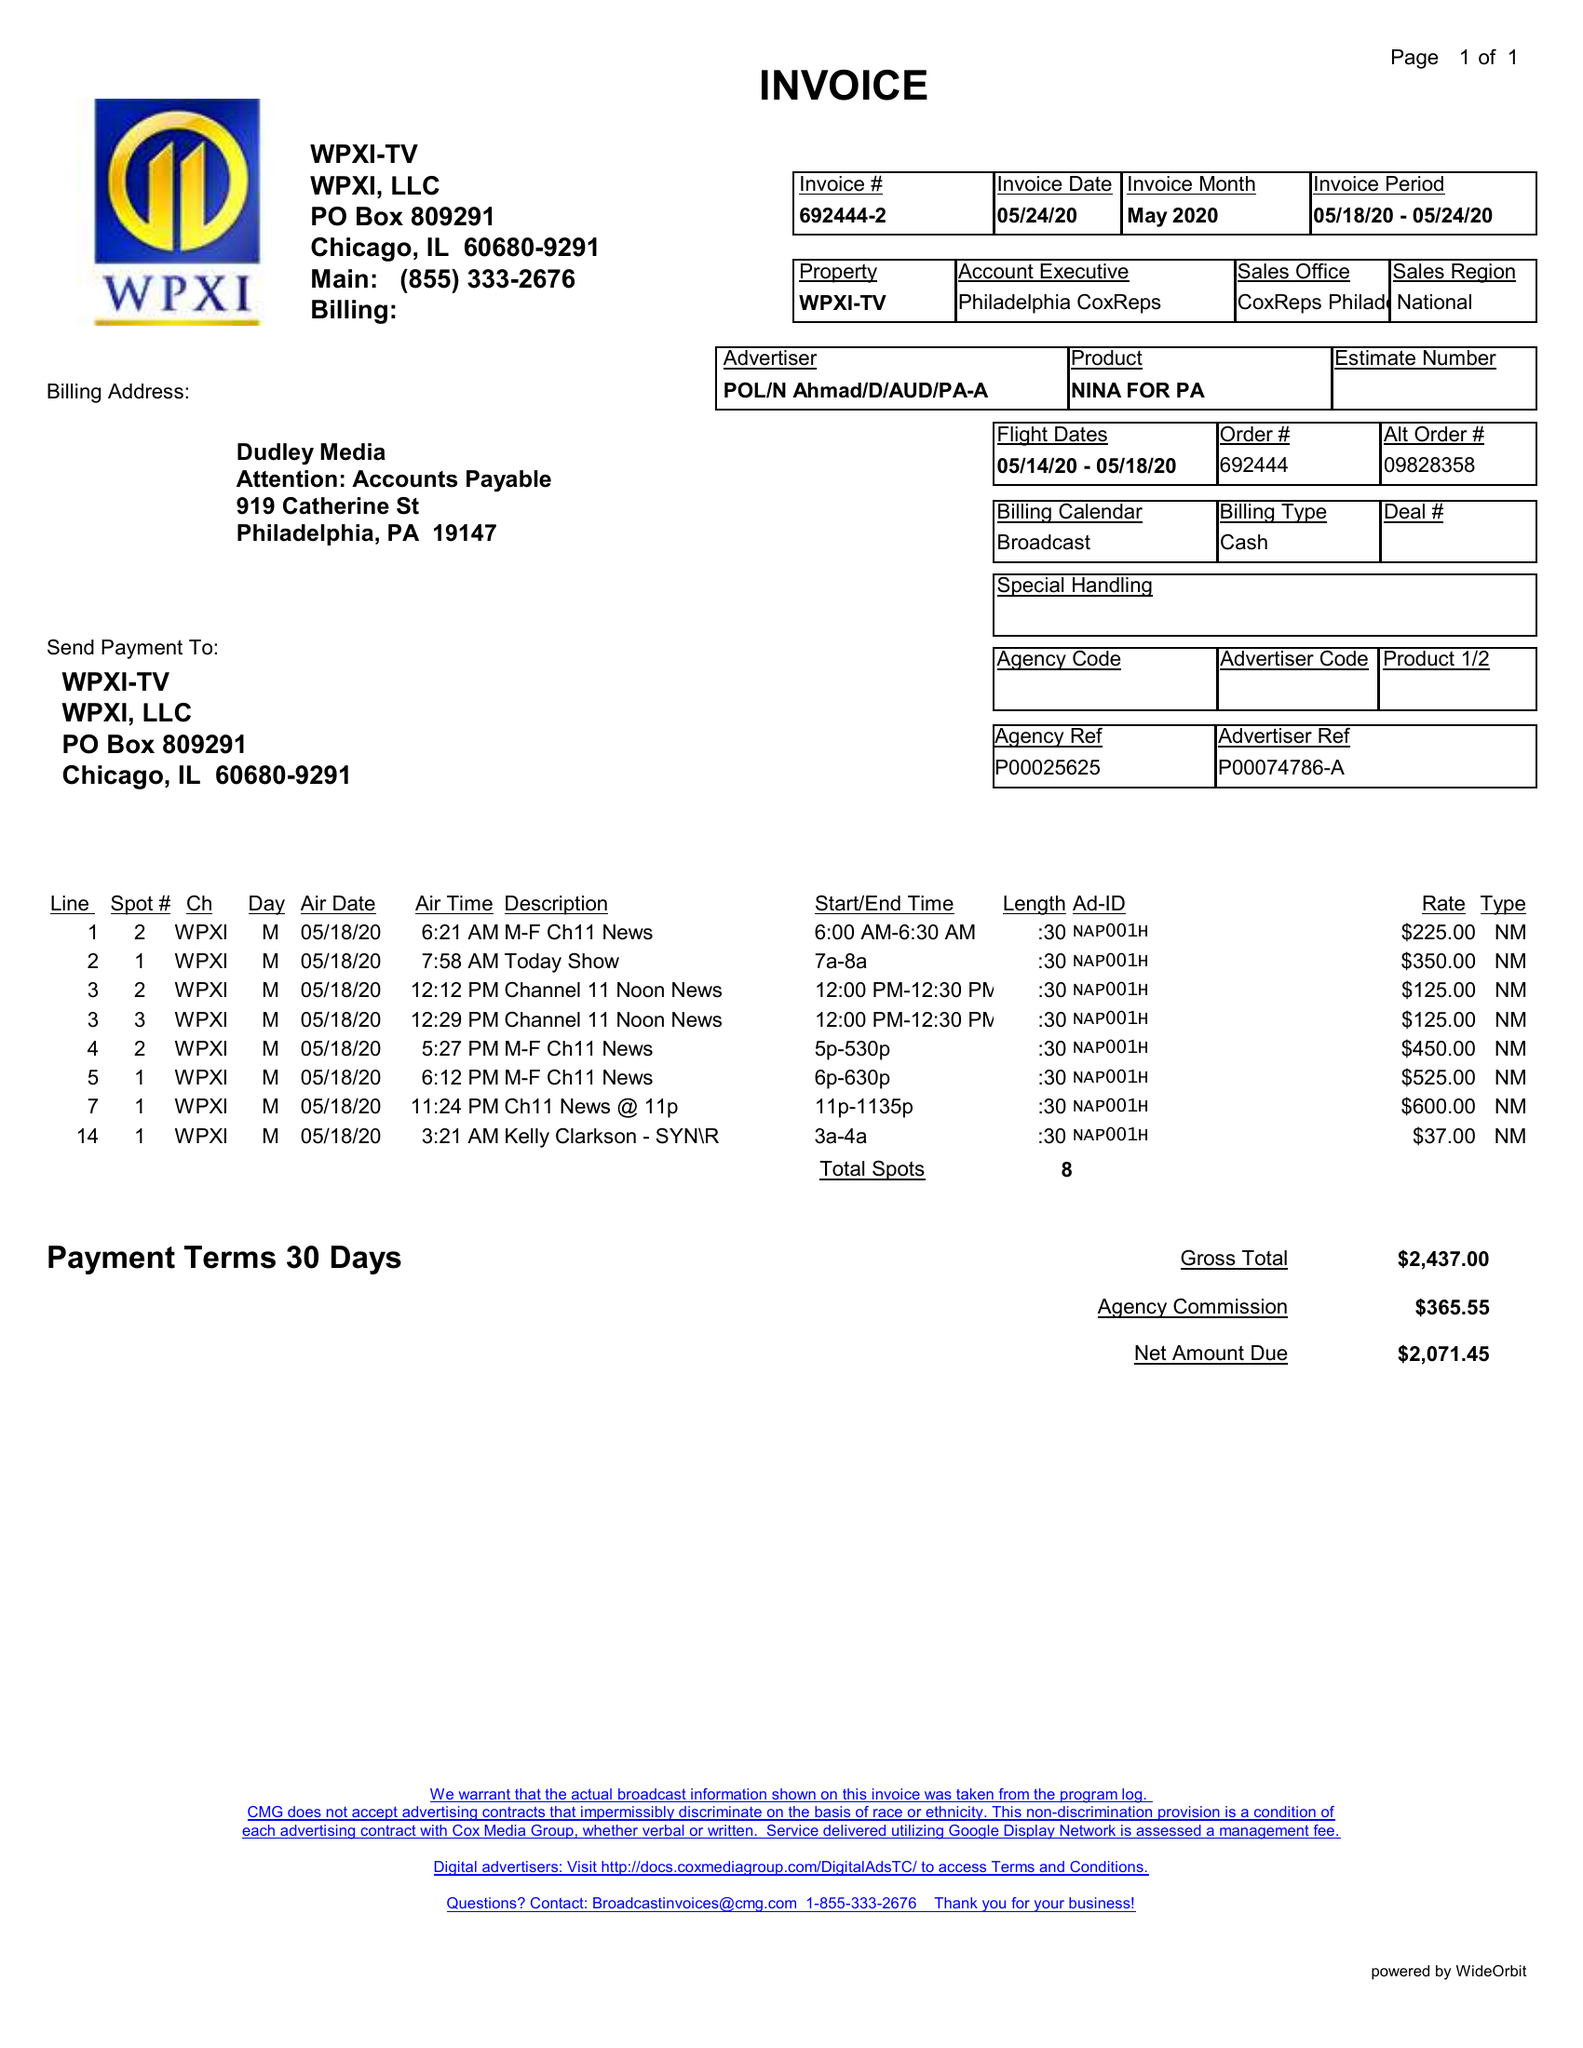What is the value for the flight_from?
Answer the question using a single word or phrase. 05/14/20 